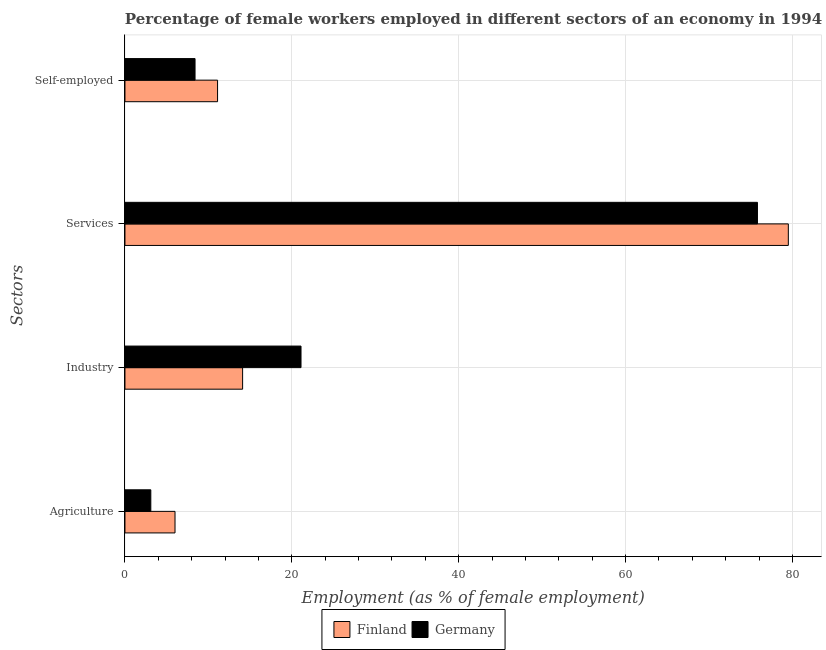How many different coloured bars are there?
Offer a terse response. 2. Are the number of bars per tick equal to the number of legend labels?
Provide a succinct answer. Yes. How many bars are there on the 4th tick from the top?
Your answer should be very brief. 2. What is the label of the 1st group of bars from the top?
Offer a very short reply. Self-employed. What is the percentage of self employed female workers in Germany?
Offer a terse response. 8.4. Across all countries, what is the maximum percentage of female workers in agriculture?
Offer a very short reply. 6. Across all countries, what is the minimum percentage of female workers in industry?
Give a very brief answer. 14.1. In which country was the percentage of self employed female workers minimum?
Provide a short and direct response. Germany. What is the total percentage of self employed female workers in the graph?
Provide a short and direct response. 19.5. What is the difference between the percentage of female workers in services in Finland and that in Germany?
Your answer should be compact. 3.7. What is the difference between the percentage of self employed female workers in Germany and the percentage of female workers in agriculture in Finland?
Give a very brief answer. 2.4. What is the average percentage of female workers in industry per country?
Provide a short and direct response. 17.6. What is the difference between the percentage of female workers in industry and percentage of female workers in agriculture in Germany?
Give a very brief answer. 18. In how many countries, is the percentage of female workers in services greater than 8 %?
Provide a short and direct response. 2. What is the ratio of the percentage of female workers in agriculture in Finland to that in Germany?
Give a very brief answer. 1.94. Is the difference between the percentage of female workers in services in Finland and Germany greater than the difference between the percentage of female workers in industry in Finland and Germany?
Offer a terse response. Yes. What is the difference between the highest and the second highest percentage of female workers in services?
Ensure brevity in your answer.  3.7. What is the difference between the highest and the lowest percentage of female workers in services?
Give a very brief answer. 3.7. In how many countries, is the percentage of female workers in industry greater than the average percentage of female workers in industry taken over all countries?
Offer a terse response. 1. What does the 1st bar from the top in Industry represents?
Ensure brevity in your answer.  Germany. What does the 2nd bar from the bottom in Services represents?
Your answer should be compact. Germany. What is the difference between two consecutive major ticks on the X-axis?
Your response must be concise. 20. Does the graph contain any zero values?
Provide a succinct answer. No. How many legend labels are there?
Provide a succinct answer. 2. How are the legend labels stacked?
Provide a short and direct response. Horizontal. What is the title of the graph?
Ensure brevity in your answer.  Percentage of female workers employed in different sectors of an economy in 1994. What is the label or title of the X-axis?
Your response must be concise. Employment (as % of female employment). What is the label or title of the Y-axis?
Your response must be concise. Sectors. What is the Employment (as % of female employment) of Finland in Agriculture?
Make the answer very short. 6. What is the Employment (as % of female employment) in Germany in Agriculture?
Offer a very short reply. 3.1. What is the Employment (as % of female employment) in Finland in Industry?
Make the answer very short. 14.1. What is the Employment (as % of female employment) of Germany in Industry?
Offer a very short reply. 21.1. What is the Employment (as % of female employment) of Finland in Services?
Make the answer very short. 79.5. What is the Employment (as % of female employment) in Germany in Services?
Your response must be concise. 75.8. What is the Employment (as % of female employment) in Finland in Self-employed?
Provide a short and direct response. 11.1. What is the Employment (as % of female employment) in Germany in Self-employed?
Offer a terse response. 8.4. Across all Sectors, what is the maximum Employment (as % of female employment) of Finland?
Keep it short and to the point. 79.5. Across all Sectors, what is the maximum Employment (as % of female employment) in Germany?
Make the answer very short. 75.8. Across all Sectors, what is the minimum Employment (as % of female employment) of Finland?
Offer a terse response. 6. Across all Sectors, what is the minimum Employment (as % of female employment) in Germany?
Offer a very short reply. 3.1. What is the total Employment (as % of female employment) of Finland in the graph?
Keep it short and to the point. 110.7. What is the total Employment (as % of female employment) of Germany in the graph?
Offer a very short reply. 108.4. What is the difference between the Employment (as % of female employment) in Germany in Agriculture and that in Industry?
Make the answer very short. -18. What is the difference between the Employment (as % of female employment) of Finland in Agriculture and that in Services?
Make the answer very short. -73.5. What is the difference between the Employment (as % of female employment) in Germany in Agriculture and that in Services?
Ensure brevity in your answer.  -72.7. What is the difference between the Employment (as % of female employment) in Finland in Agriculture and that in Self-employed?
Provide a short and direct response. -5.1. What is the difference between the Employment (as % of female employment) of Germany in Agriculture and that in Self-employed?
Offer a terse response. -5.3. What is the difference between the Employment (as % of female employment) in Finland in Industry and that in Services?
Offer a terse response. -65.4. What is the difference between the Employment (as % of female employment) of Germany in Industry and that in Services?
Your answer should be compact. -54.7. What is the difference between the Employment (as % of female employment) in Finland in Industry and that in Self-employed?
Offer a very short reply. 3. What is the difference between the Employment (as % of female employment) of Germany in Industry and that in Self-employed?
Your response must be concise. 12.7. What is the difference between the Employment (as % of female employment) in Finland in Services and that in Self-employed?
Your answer should be very brief. 68.4. What is the difference between the Employment (as % of female employment) in Germany in Services and that in Self-employed?
Keep it short and to the point. 67.4. What is the difference between the Employment (as % of female employment) in Finland in Agriculture and the Employment (as % of female employment) in Germany in Industry?
Offer a very short reply. -15.1. What is the difference between the Employment (as % of female employment) in Finland in Agriculture and the Employment (as % of female employment) in Germany in Services?
Make the answer very short. -69.8. What is the difference between the Employment (as % of female employment) in Finland in Agriculture and the Employment (as % of female employment) in Germany in Self-employed?
Offer a terse response. -2.4. What is the difference between the Employment (as % of female employment) of Finland in Industry and the Employment (as % of female employment) of Germany in Services?
Provide a succinct answer. -61.7. What is the difference between the Employment (as % of female employment) in Finland in Services and the Employment (as % of female employment) in Germany in Self-employed?
Provide a succinct answer. 71.1. What is the average Employment (as % of female employment) in Finland per Sectors?
Keep it short and to the point. 27.68. What is the average Employment (as % of female employment) of Germany per Sectors?
Make the answer very short. 27.1. What is the difference between the Employment (as % of female employment) of Finland and Employment (as % of female employment) of Germany in Industry?
Your response must be concise. -7. What is the difference between the Employment (as % of female employment) of Finland and Employment (as % of female employment) of Germany in Services?
Keep it short and to the point. 3.7. What is the ratio of the Employment (as % of female employment) in Finland in Agriculture to that in Industry?
Your response must be concise. 0.43. What is the ratio of the Employment (as % of female employment) of Germany in Agriculture to that in Industry?
Provide a short and direct response. 0.15. What is the ratio of the Employment (as % of female employment) of Finland in Agriculture to that in Services?
Provide a short and direct response. 0.08. What is the ratio of the Employment (as % of female employment) of Germany in Agriculture to that in Services?
Your response must be concise. 0.04. What is the ratio of the Employment (as % of female employment) in Finland in Agriculture to that in Self-employed?
Your response must be concise. 0.54. What is the ratio of the Employment (as % of female employment) of Germany in Agriculture to that in Self-employed?
Provide a short and direct response. 0.37. What is the ratio of the Employment (as % of female employment) in Finland in Industry to that in Services?
Ensure brevity in your answer.  0.18. What is the ratio of the Employment (as % of female employment) of Germany in Industry to that in Services?
Your answer should be compact. 0.28. What is the ratio of the Employment (as % of female employment) in Finland in Industry to that in Self-employed?
Your answer should be very brief. 1.27. What is the ratio of the Employment (as % of female employment) in Germany in Industry to that in Self-employed?
Make the answer very short. 2.51. What is the ratio of the Employment (as % of female employment) in Finland in Services to that in Self-employed?
Your response must be concise. 7.16. What is the ratio of the Employment (as % of female employment) of Germany in Services to that in Self-employed?
Offer a terse response. 9.02. What is the difference between the highest and the second highest Employment (as % of female employment) in Finland?
Offer a terse response. 65.4. What is the difference between the highest and the second highest Employment (as % of female employment) in Germany?
Your answer should be very brief. 54.7. What is the difference between the highest and the lowest Employment (as % of female employment) of Finland?
Provide a succinct answer. 73.5. What is the difference between the highest and the lowest Employment (as % of female employment) in Germany?
Provide a short and direct response. 72.7. 